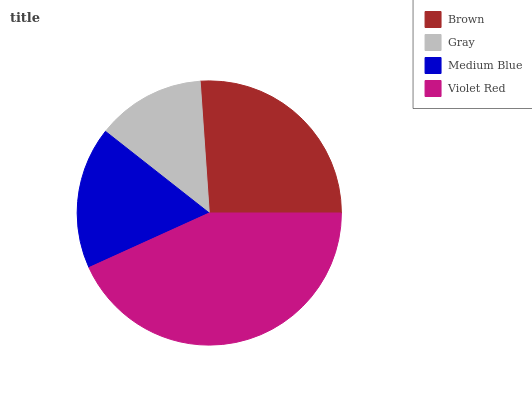Is Gray the minimum?
Answer yes or no. Yes. Is Violet Red the maximum?
Answer yes or no. Yes. Is Medium Blue the minimum?
Answer yes or no. No. Is Medium Blue the maximum?
Answer yes or no. No. Is Medium Blue greater than Gray?
Answer yes or no. Yes. Is Gray less than Medium Blue?
Answer yes or no. Yes. Is Gray greater than Medium Blue?
Answer yes or no. No. Is Medium Blue less than Gray?
Answer yes or no. No. Is Brown the high median?
Answer yes or no. Yes. Is Medium Blue the low median?
Answer yes or no. Yes. Is Gray the high median?
Answer yes or no. No. Is Gray the low median?
Answer yes or no. No. 